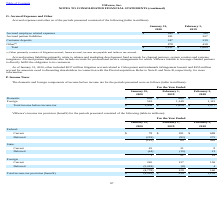From Vmware's financial document, Which years does the table provide information for accrued expenses and other? The document shows two values: 2020 and 2019. From the document: "2020 2019 2020 2019..." Also, What were the accrued partner liabilities in 2019? According to the financial document, 207 (in millions). The relevant text states: "Accrued partner liabilities 181 207..." Also, What were the customer deposits in 2020? According to the financial document, 247 (in millions). The relevant text states: "Customer deposits 247 239..." Also, can you calculate: What was the change in Customer deposits between 2019 and 2020? Based on the calculation: 247-239, the result is 8 (in millions). This is based on the information: "Customer deposits 247 239 Customer deposits 247 239..." The key data points involved are: 239, 247. Also, How many years did Other exceed $500 million? Based on the analysis, there are 1 instances. The counting process: 2020. Also, can you calculate: What was the change in the total accrued expenses between 2019 and 2020? To answer this question, I need to perform calculations using the financial data. The calculation is: (2,151-1,664)/1,664, which equals 29.27 (percentage). This is based on the information: "Total $ 2,151 $ 1,664 Total $ 2,151 $ 1,664..." The key data points involved are: 1,664, 2,151. 